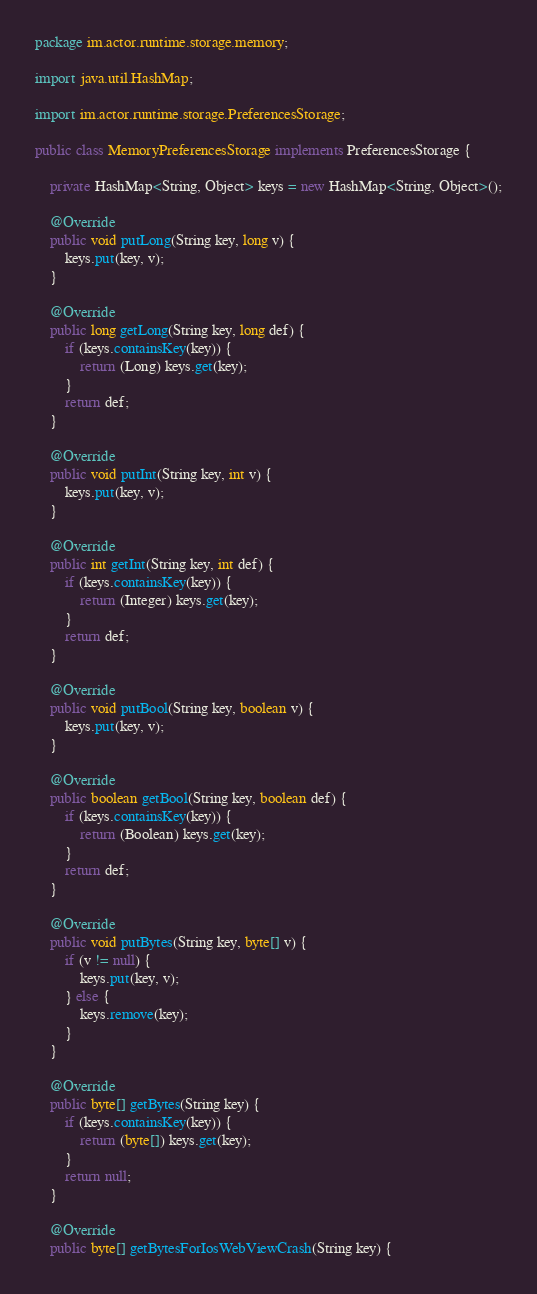Convert code to text. <code><loc_0><loc_0><loc_500><loc_500><_Java_>package im.actor.runtime.storage.memory;

import java.util.HashMap;

import im.actor.runtime.storage.PreferencesStorage;

public class MemoryPreferencesStorage implements PreferencesStorage {

    private HashMap<String, Object> keys = new HashMap<String, Object>();

    @Override
    public void putLong(String key, long v) {
        keys.put(key, v);
    }

    @Override
    public long getLong(String key, long def) {
        if (keys.containsKey(key)) {
            return (Long) keys.get(key);
        }
        return def;
    }

    @Override
    public void putInt(String key, int v) {
        keys.put(key, v);
    }

    @Override
    public int getInt(String key, int def) {
        if (keys.containsKey(key)) {
            return (Integer) keys.get(key);
        }
        return def;
    }

    @Override
    public void putBool(String key, boolean v) {
        keys.put(key, v);
    }

    @Override
    public boolean getBool(String key, boolean def) {
        if (keys.containsKey(key)) {
            return (Boolean) keys.get(key);
        }
        return def;
    }

    @Override
    public void putBytes(String key, byte[] v) {
        if (v != null) {
            keys.put(key, v);
        } else {
            keys.remove(key);
        }
    }

    @Override
    public byte[] getBytes(String key) {
        if (keys.containsKey(key)) {
            return (byte[]) keys.get(key);
        }
        return null;
    }

    @Override
    public byte[] getBytesForIosWebViewCrash(String key) {</code> 